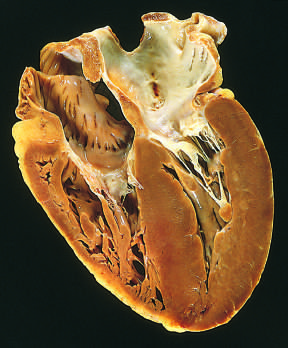what is on the lower right in this apical four-chamber view of the heart?
Answer the question using a single word or phrase. Left ventricle 